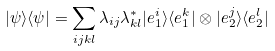Convert formula to latex. <formula><loc_0><loc_0><loc_500><loc_500>| \psi \rangle \langle \psi | = \sum _ { i j k l } \lambda _ { i j } \lambda _ { k l } ^ { * } | e _ { 1 } ^ { i } \rangle \langle e _ { 1 } ^ { k } | \otimes | e _ { 2 } ^ { j } \rangle \langle e _ { 2 } ^ { l } |</formula> 